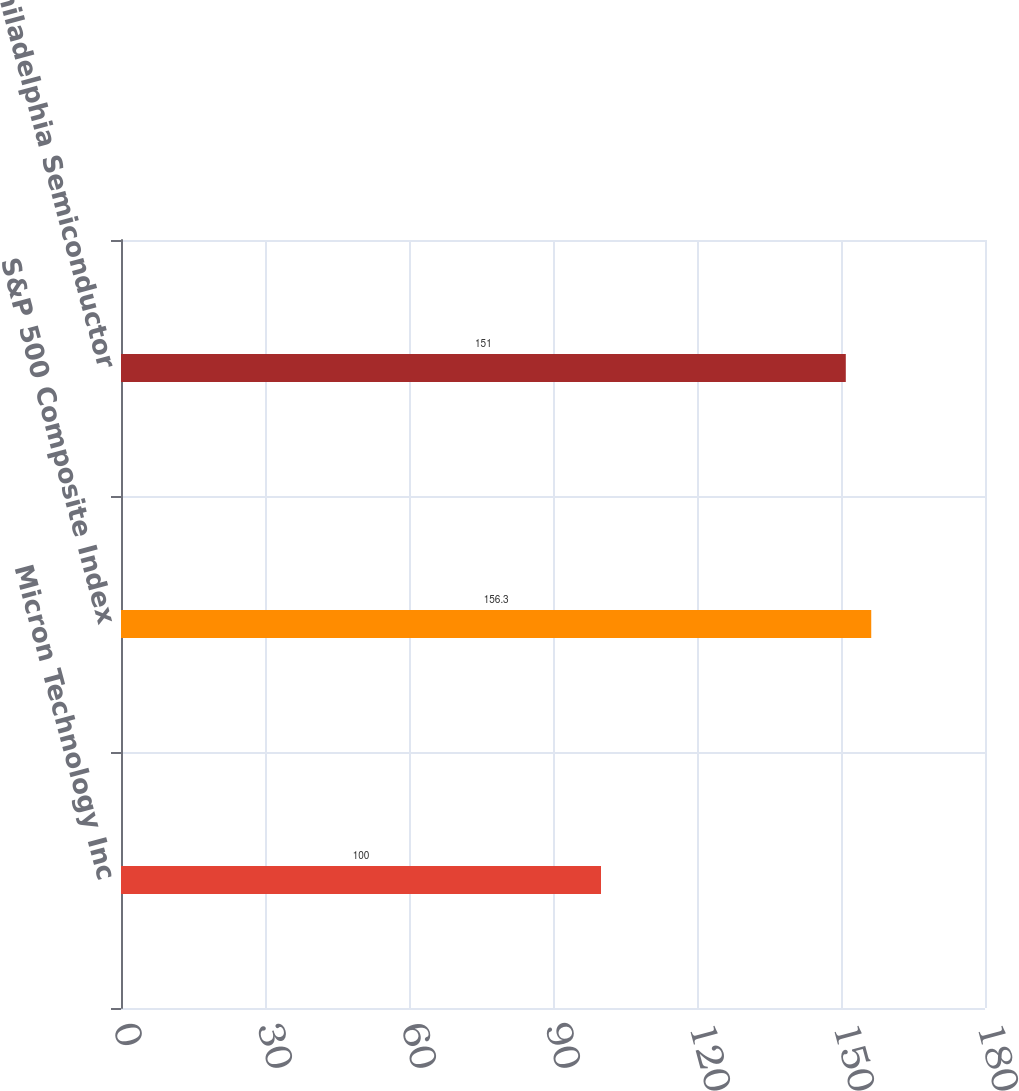<chart> <loc_0><loc_0><loc_500><loc_500><bar_chart><fcel>Micron Technology Inc<fcel>S&P 500 Composite Index<fcel>Philadelphia Semiconductor<nl><fcel>100<fcel>156.3<fcel>151<nl></chart> 